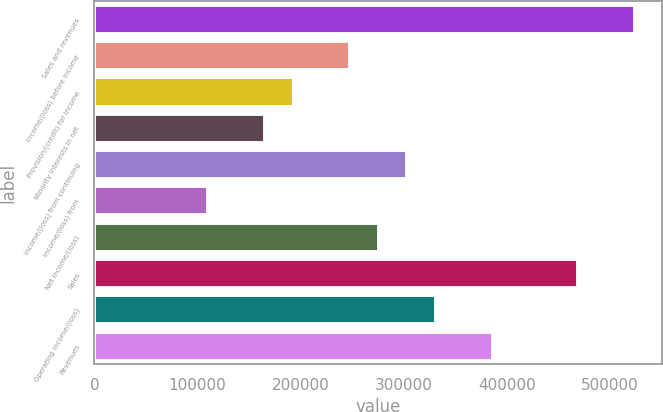Convert chart to OTSL. <chart><loc_0><loc_0><loc_500><loc_500><bar_chart><fcel>Sales and revenues<fcel>Income/(loss) before income<fcel>Provision/(credit) for income<fcel>Minority interests in net<fcel>Income/(loss) from continuing<fcel>Income/(loss) from<fcel>Net income/(loss)<fcel>Sales<fcel>Operating income/(loss)<fcel>Revenues<nl><fcel>524286<fcel>248346<fcel>193158<fcel>165564<fcel>303534<fcel>110376<fcel>275940<fcel>469098<fcel>331128<fcel>386316<nl></chart> 